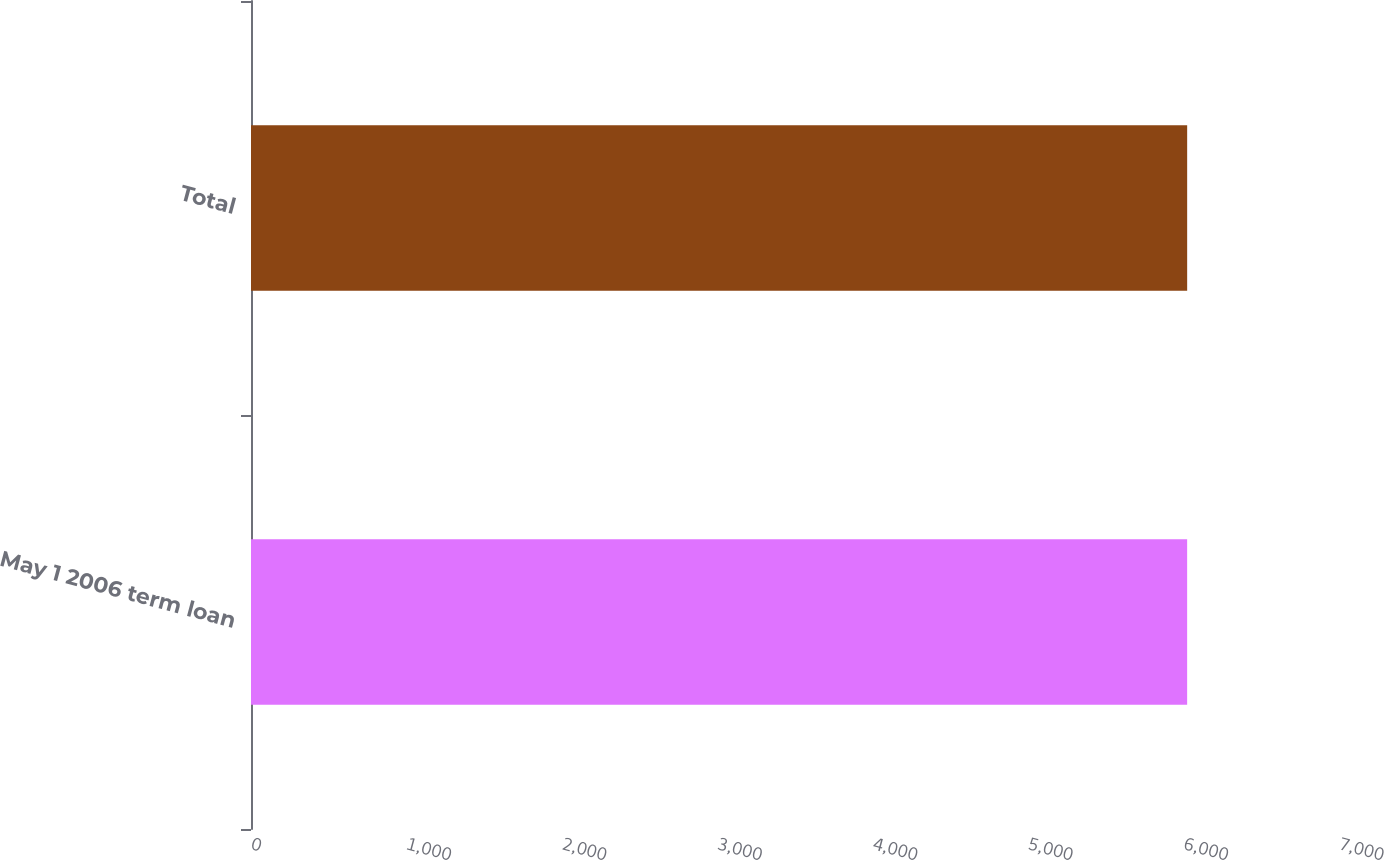Convert chart to OTSL. <chart><loc_0><loc_0><loc_500><loc_500><bar_chart><fcel>May 1 2006 term loan<fcel>Total<nl><fcel>6023<fcel>6023.1<nl></chart> 